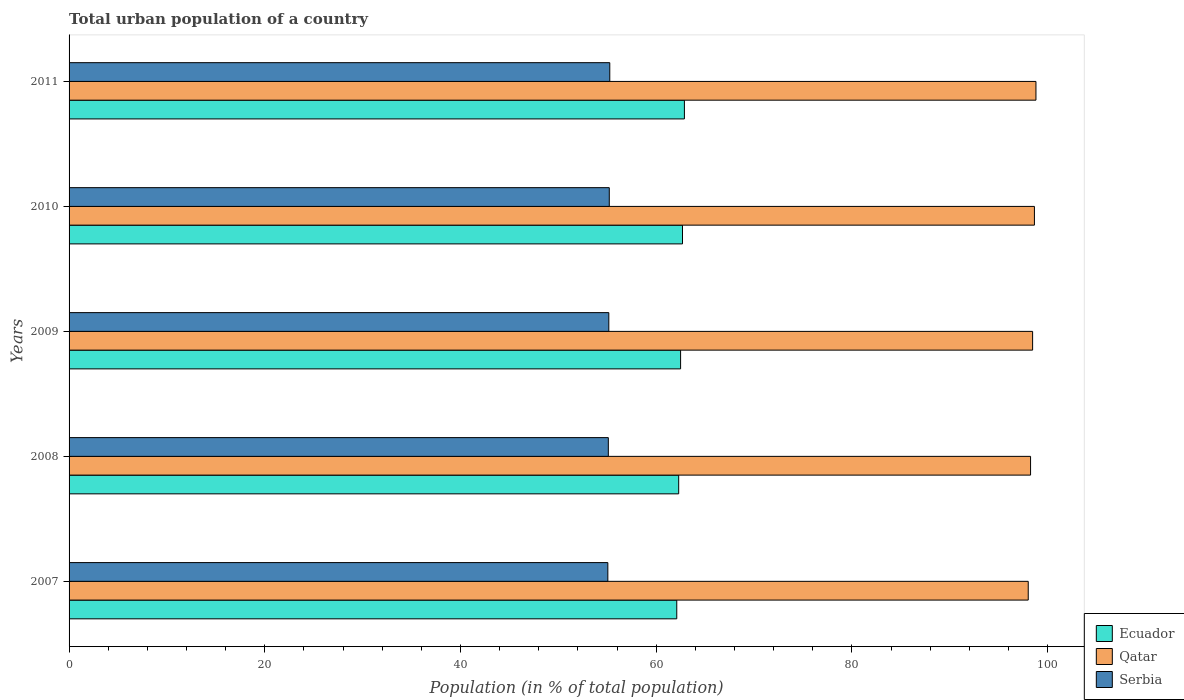How many groups of bars are there?
Your response must be concise. 5. Are the number of bars per tick equal to the number of legend labels?
Your answer should be compact. Yes. Are the number of bars on each tick of the Y-axis equal?
Ensure brevity in your answer.  Yes. How many bars are there on the 5th tick from the top?
Your answer should be very brief. 3. What is the urban population in Ecuador in 2011?
Ensure brevity in your answer.  62.88. Across all years, what is the maximum urban population in Serbia?
Your answer should be very brief. 55.26. Across all years, what is the minimum urban population in Ecuador?
Offer a very short reply. 62.1. In which year was the urban population in Qatar maximum?
Your answer should be compact. 2011. In which year was the urban population in Qatar minimum?
Keep it short and to the point. 2007. What is the total urban population in Serbia in the graph?
Keep it short and to the point. 275.8. What is the difference between the urban population in Qatar in 2007 and that in 2010?
Provide a succinct answer. -0.63. What is the difference between the urban population in Serbia in 2009 and the urban population in Ecuador in 2007?
Provide a succinct answer. -6.95. What is the average urban population in Ecuador per year?
Provide a short and direct response. 62.49. In the year 2010, what is the difference between the urban population in Serbia and urban population in Ecuador?
Offer a very short reply. -7.48. In how many years, is the urban population in Ecuador greater than 40 %?
Your response must be concise. 5. What is the ratio of the urban population in Ecuador in 2007 to that in 2009?
Offer a very short reply. 0.99. Is the urban population in Serbia in 2008 less than that in 2009?
Make the answer very short. Yes. Is the difference between the urban population in Serbia in 2008 and 2009 greater than the difference between the urban population in Ecuador in 2008 and 2009?
Make the answer very short. Yes. What is the difference between the highest and the second highest urban population in Qatar?
Your answer should be very brief. 0.16. What is the difference between the highest and the lowest urban population in Ecuador?
Give a very brief answer. 0.78. In how many years, is the urban population in Ecuador greater than the average urban population in Ecuador taken over all years?
Your answer should be very brief. 3. Is the sum of the urban population in Ecuador in 2010 and 2011 greater than the maximum urban population in Qatar across all years?
Ensure brevity in your answer.  Yes. What does the 1st bar from the top in 2007 represents?
Offer a very short reply. Serbia. What does the 2nd bar from the bottom in 2009 represents?
Your answer should be very brief. Qatar. Is it the case that in every year, the sum of the urban population in Qatar and urban population in Ecuador is greater than the urban population in Serbia?
Give a very brief answer. Yes. How many bars are there?
Ensure brevity in your answer.  15. Are all the bars in the graph horizontal?
Keep it short and to the point. Yes. Does the graph contain any zero values?
Make the answer very short. No. Does the graph contain grids?
Your response must be concise. No. Where does the legend appear in the graph?
Your response must be concise. Bottom right. How many legend labels are there?
Your answer should be compact. 3. How are the legend labels stacked?
Provide a succinct answer. Vertical. What is the title of the graph?
Give a very brief answer. Total urban population of a country. What is the label or title of the X-axis?
Your response must be concise. Population (in % of total population). What is the Population (in % of total population) in Ecuador in 2007?
Offer a terse response. 62.1. What is the Population (in % of total population) in Qatar in 2007?
Give a very brief answer. 98.02. What is the Population (in % of total population) in Serbia in 2007?
Provide a short and direct response. 55.06. What is the Population (in % of total population) in Ecuador in 2008?
Your answer should be very brief. 62.3. What is the Population (in % of total population) in Qatar in 2008?
Offer a very short reply. 98.26. What is the Population (in % of total population) in Serbia in 2008?
Make the answer very short. 55.11. What is the Population (in % of total population) of Ecuador in 2009?
Make the answer very short. 62.49. What is the Population (in % of total population) of Qatar in 2009?
Provide a succinct answer. 98.47. What is the Population (in % of total population) in Serbia in 2009?
Your response must be concise. 55.16. What is the Population (in % of total population) of Ecuador in 2010?
Keep it short and to the point. 62.69. What is the Population (in % of total population) in Qatar in 2010?
Offer a very short reply. 98.66. What is the Population (in % of total population) in Serbia in 2010?
Your answer should be very brief. 55.21. What is the Population (in % of total population) in Ecuador in 2011?
Your answer should be compact. 62.88. What is the Population (in % of total population) of Qatar in 2011?
Your answer should be compact. 98.81. What is the Population (in % of total population) of Serbia in 2011?
Provide a succinct answer. 55.26. Across all years, what is the maximum Population (in % of total population) in Ecuador?
Your response must be concise. 62.88. Across all years, what is the maximum Population (in % of total population) in Qatar?
Keep it short and to the point. 98.81. Across all years, what is the maximum Population (in % of total population) of Serbia?
Ensure brevity in your answer.  55.26. Across all years, what is the minimum Population (in % of total population) of Ecuador?
Offer a very short reply. 62.1. Across all years, what is the minimum Population (in % of total population) of Qatar?
Keep it short and to the point. 98.02. Across all years, what is the minimum Population (in % of total population) of Serbia?
Your response must be concise. 55.06. What is the total Population (in % of total population) in Ecuador in the graph?
Provide a succinct answer. 312.47. What is the total Population (in % of total population) of Qatar in the graph?
Keep it short and to the point. 492.22. What is the total Population (in % of total population) in Serbia in the graph?
Ensure brevity in your answer.  275.8. What is the difference between the Population (in % of total population) in Ecuador in 2007 and that in 2008?
Provide a short and direct response. -0.2. What is the difference between the Population (in % of total population) in Qatar in 2007 and that in 2008?
Offer a very short reply. -0.24. What is the difference between the Population (in % of total population) of Ecuador in 2007 and that in 2009?
Ensure brevity in your answer.  -0.39. What is the difference between the Population (in % of total population) in Qatar in 2007 and that in 2009?
Your answer should be very brief. -0.45. What is the difference between the Population (in % of total population) of Serbia in 2007 and that in 2009?
Make the answer very short. -0.1. What is the difference between the Population (in % of total population) in Ecuador in 2007 and that in 2010?
Provide a succinct answer. -0.59. What is the difference between the Population (in % of total population) of Qatar in 2007 and that in 2010?
Give a very brief answer. -0.63. What is the difference between the Population (in % of total population) in Serbia in 2007 and that in 2010?
Ensure brevity in your answer.  -0.15. What is the difference between the Population (in % of total population) of Ecuador in 2007 and that in 2011?
Your answer should be compact. -0.78. What is the difference between the Population (in % of total population) of Qatar in 2007 and that in 2011?
Offer a very short reply. -0.79. What is the difference between the Population (in % of total population) of Serbia in 2007 and that in 2011?
Keep it short and to the point. -0.2. What is the difference between the Population (in % of total population) of Ecuador in 2008 and that in 2009?
Your answer should be compact. -0.2. What is the difference between the Population (in % of total population) in Qatar in 2008 and that in 2009?
Ensure brevity in your answer.  -0.21. What is the difference between the Population (in % of total population) in Serbia in 2008 and that in 2009?
Make the answer very short. -0.05. What is the difference between the Population (in % of total population) in Ecuador in 2008 and that in 2010?
Offer a terse response. -0.39. What is the difference between the Population (in % of total population) in Qatar in 2008 and that in 2010?
Offer a terse response. -0.39. What is the difference between the Population (in % of total population) in Serbia in 2008 and that in 2010?
Provide a short and direct response. -0.1. What is the difference between the Population (in % of total population) of Ecuador in 2008 and that in 2011?
Make the answer very short. -0.58. What is the difference between the Population (in % of total population) in Qatar in 2008 and that in 2011?
Your response must be concise. -0.55. What is the difference between the Population (in % of total population) of Serbia in 2008 and that in 2011?
Your response must be concise. -0.15. What is the difference between the Population (in % of total population) of Ecuador in 2009 and that in 2010?
Make the answer very short. -0.2. What is the difference between the Population (in % of total population) in Qatar in 2009 and that in 2010?
Offer a terse response. -0.18. What is the difference between the Population (in % of total population) of Serbia in 2009 and that in 2010?
Give a very brief answer. -0.05. What is the difference between the Population (in % of total population) in Ecuador in 2009 and that in 2011?
Your answer should be very brief. -0.39. What is the difference between the Population (in % of total population) in Qatar in 2009 and that in 2011?
Provide a short and direct response. -0.34. What is the difference between the Population (in % of total population) in Serbia in 2009 and that in 2011?
Give a very brief answer. -0.1. What is the difference between the Population (in % of total population) of Ecuador in 2010 and that in 2011?
Provide a succinct answer. -0.2. What is the difference between the Population (in % of total population) in Qatar in 2010 and that in 2011?
Offer a terse response. -0.16. What is the difference between the Population (in % of total population) of Ecuador in 2007 and the Population (in % of total population) of Qatar in 2008?
Provide a succinct answer. -36.16. What is the difference between the Population (in % of total population) in Ecuador in 2007 and the Population (in % of total population) in Serbia in 2008?
Give a very brief answer. 6.99. What is the difference between the Population (in % of total population) in Qatar in 2007 and the Population (in % of total population) in Serbia in 2008?
Provide a succinct answer. 42.91. What is the difference between the Population (in % of total population) of Ecuador in 2007 and the Population (in % of total population) of Qatar in 2009?
Give a very brief answer. -36.37. What is the difference between the Population (in % of total population) of Ecuador in 2007 and the Population (in % of total population) of Serbia in 2009?
Provide a succinct answer. 6.95. What is the difference between the Population (in % of total population) in Qatar in 2007 and the Population (in % of total population) in Serbia in 2009?
Provide a short and direct response. 42.86. What is the difference between the Population (in % of total population) in Ecuador in 2007 and the Population (in % of total population) in Qatar in 2010?
Provide a succinct answer. -36.55. What is the difference between the Population (in % of total population) in Ecuador in 2007 and the Population (in % of total population) in Serbia in 2010?
Your answer should be compact. 6.9. What is the difference between the Population (in % of total population) in Qatar in 2007 and the Population (in % of total population) in Serbia in 2010?
Provide a short and direct response. 42.81. What is the difference between the Population (in % of total population) of Ecuador in 2007 and the Population (in % of total population) of Qatar in 2011?
Make the answer very short. -36.71. What is the difference between the Population (in % of total population) of Ecuador in 2007 and the Population (in % of total population) of Serbia in 2011?
Keep it short and to the point. 6.85. What is the difference between the Population (in % of total population) of Qatar in 2007 and the Population (in % of total population) of Serbia in 2011?
Ensure brevity in your answer.  42.77. What is the difference between the Population (in % of total population) in Ecuador in 2008 and the Population (in % of total population) in Qatar in 2009?
Offer a very short reply. -36.17. What is the difference between the Population (in % of total population) in Ecuador in 2008 and the Population (in % of total population) in Serbia in 2009?
Provide a succinct answer. 7.14. What is the difference between the Population (in % of total population) of Qatar in 2008 and the Population (in % of total population) of Serbia in 2009?
Ensure brevity in your answer.  43.1. What is the difference between the Population (in % of total population) in Ecuador in 2008 and the Population (in % of total population) in Qatar in 2010?
Your answer should be very brief. -36.35. What is the difference between the Population (in % of total population) in Ecuador in 2008 and the Population (in % of total population) in Serbia in 2010?
Your response must be concise. 7.09. What is the difference between the Population (in % of total population) of Qatar in 2008 and the Population (in % of total population) of Serbia in 2010?
Ensure brevity in your answer.  43.05. What is the difference between the Population (in % of total population) in Ecuador in 2008 and the Population (in % of total population) in Qatar in 2011?
Provide a short and direct response. -36.51. What is the difference between the Population (in % of total population) in Ecuador in 2008 and the Population (in % of total population) in Serbia in 2011?
Your answer should be compact. 7.04. What is the difference between the Population (in % of total population) in Qatar in 2008 and the Population (in % of total population) in Serbia in 2011?
Your answer should be very brief. 43. What is the difference between the Population (in % of total population) of Ecuador in 2009 and the Population (in % of total population) of Qatar in 2010?
Offer a terse response. -36.16. What is the difference between the Population (in % of total population) in Ecuador in 2009 and the Population (in % of total population) in Serbia in 2010?
Keep it short and to the point. 7.29. What is the difference between the Population (in % of total population) in Qatar in 2009 and the Population (in % of total population) in Serbia in 2010?
Your answer should be compact. 43.26. What is the difference between the Population (in % of total population) in Ecuador in 2009 and the Population (in % of total population) in Qatar in 2011?
Your response must be concise. -36.32. What is the difference between the Population (in % of total population) in Ecuador in 2009 and the Population (in % of total population) in Serbia in 2011?
Your answer should be very brief. 7.24. What is the difference between the Population (in % of total population) of Qatar in 2009 and the Population (in % of total population) of Serbia in 2011?
Offer a terse response. 43.21. What is the difference between the Population (in % of total population) of Ecuador in 2010 and the Population (in % of total population) of Qatar in 2011?
Provide a short and direct response. -36.12. What is the difference between the Population (in % of total population) in Ecuador in 2010 and the Population (in % of total population) in Serbia in 2011?
Keep it short and to the point. 7.43. What is the difference between the Population (in % of total population) in Qatar in 2010 and the Population (in % of total population) in Serbia in 2011?
Give a very brief answer. 43.4. What is the average Population (in % of total population) of Ecuador per year?
Give a very brief answer. 62.49. What is the average Population (in % of total population) of Qatar per year?
Your response must be concise. 98.44. What is the average Population (in % of total population) of Serbia per year?
Provide a short and direct response. 55.16. In the year 2007, what is the difference between the Population (in % of total population) of Ecuador and Population (in % of total population) of Qatar?
Provide a short and direct response. -35.92. In the year 2007, what is the difference between the Population (in % of total population) of Ecuador and Population (in % of total population) of Serbia?
Your answer should be very brief. 7.04. In the year 2007, what is the difference between the Population (in % of total population) of Qatar and Population (in % of total population) of Serbia?
Keep it short and to the point. 42.96. In the year 2008, what is the difference between the Population (in % of total population) of Ecuador and Population (in % of total population) of Qatar?
Keep it short and to the point. -35.96. In the year 2008, what is the difference between the Population (in % of total population) of Ecuador and Population (in % of total population) of Serbia?
Your response must be concise. 7.19. In the year 2008, what is the difference between the Population (in % of total population) of Qatar and Population (in % of total population) of Serbia?
Provide a succinct answer. 43.15. In the year 2009, what is the difference between the Population (in % of total population) in Ecuador and Population (in % of total population) in Qatar?
Your answer should be compact. -35.98. In the year 2009, what is the difference between the Population (in % of total population) of Ecuador and Population (in % of total population) of Serbia?
Your response must be concise. 7.34. In the year 2009, what is the difference between the Population (in % of total population) of Qatar and Population (in % of total population) of Serbia?
Provide a short and direct response. 43.31. In the year 2010, what is the difference between the Population (in % of total population) in Ecuador and Population (in % of total population) in Qatar?
Your answer should be very brief. -35.97. In the year 2010, what is the difference between the Population (in % of total population) in Ecuador and Population (in % of total population) in Serbia?
Offer a terse response. 7.48. In the year 2010, what is the difference between the Population (in % of total population) of Qatar and Population (in % of total population) of Serbia?
Give a very brief answer. 43.45. In the year 2011, what is the difference between the Population (in % of total population) in Ecuador and Population (in % of total population) in Qatar?
Offer a very short reply. -35.93. In the year 2011, what is the difference between the Population (in % of total population) of Ecuador and Population (in % of total population) of Serbia?
Give a very brief answer. 7.63. In the year 2011, what is the difference between the Population (in % of total population) of Qatar and Population (in % of total population) of Serbia?
Offer a very short reply. 43.55. What is the ratio of the Population (in % of total population) of Qatar in 2007 to that in 2008?
Your answer should be very brief. 1. What is the ratio of the Population (in % of total population) in Serbia in 2007 to that in 2008?
Offer a very short reply. 1. What is the ratio of the Population (in % of total population) of Ecuador in 2007 to that in 2009?
Keep it short and to the point. 0.99. What is the ratio of the Population (in % of total population) of Qatar in 2007 to that in 2009?
Provide a succinct answer. 1. What is the ratio of the Population (in % of total population) of Ecuador in 2007 to that in 2010?
Your answer should be compact. 0.99. What is the ratio of the Population (in % of total population) in Ecuador in 2007 to that in 2011?
Keep it short and to the point. 0.99. What is the ratio of the Population (in % of total population) in Qatar in 2007 to that in 2011?
Your answer should be very brief. 0.99. What is the ratio of the Population (in % of total population) of Ecuador in 2008 to that in 2009?
Give a very brief answer. 1. What is the ratio of the Population (in % of total population) in Qatar in 2008 to that in 2009?
Provide a succinct answer. 1. What is the ratio of the Population (in % of total population) in Qatar in 2008 to that in 2010?
Your response must be concise. 1. What is the ratio of the Population (in % of total population) of Serbia in 2008 to that in 2010?
Give a very brief answer. 1. What is the ratio of the Population (in % of total population) of Ecuador in 2008 to that in 2011?
Make the answer very short. 0.99. What is the ratio of the Population (in % of total population) of Qatar in 2008 to that in 2011?
Your response must be concise. 0.99. What is the ratio of the Population (in % of total population) of Serbia in 2008 to that in 2011?
Offer a very short reply. 1. What is the ratio of the Population (in % of total population) of Ecuador in 2009 to that in 2010?
Your answer should be very brief. 1. What is the ratio of the Population (in % of total population) in Serbia in 2009 to that in 2010?
Your answer should be very brief. 1. What is the ratio of the Population (in % of total population) in Qatar in 2010 to that in 2011?
Your response must be concise. 1. What is the ratio of the Population (in % of total population) in Serbia in 2010 to that in 2011?
Make the answer very short. 1. What is the difference between the highest and the second highest Population (in % of total population) of Ecuador?
Ensure brevity in your answer.  0.2. What is the difference between the highest and the second highest Population (in % of total population) in Qatar?
Your answer should be compact. 0.16. What is the difference between the highest and the second highest Population (in % of total population) of Serbia?
Offer a terse response. 0.05. What is the difference between the highest and the lowest Population (in % of total population) in Ecuador?
Offer a terse response. 0.78. What is the difference between the highest and the lowest Population (in % of total population) of Qatar?
Your response must be concise. 0.79. What is the difference between the highest and the lowest Population (in % of total population) in Serbia?
Give a very brief answer. 0.2. 